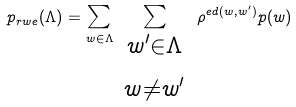Convert formula to latex. <formula><loc_0><loc_0><loc_500><loc_500>p _ { r w e } ( \Lambda ) = \sum _ { w \in \Lambda } \sum _ { \begin{array} { c } ^ { w ^ { \prime } \in \Lambda } \\ ^ { w \ne w ^ { \prime } } \end{array} } \rho ^ { e d ( w , w ^ { \prime } ) } p ( w )</formula> 